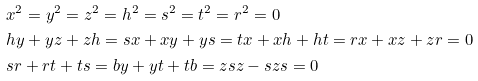Convert formula to latex. <formula><loc_0><loc_0><loc_500><loc_500>& x ^ { 2 } = y ^ { 2 } = z ^ { 2 } = h ^ { 2 } = s ^ { 2 } = t ^ { 2 } = r ^ { 2 } = 0 \\ & h y + y z + z h = s x + x y + y s = t x + x h + h t = r x + x z + z r = 0 \\ & s r + r t + t s = b y + y t + t b = z s z - s z s = 0</formula> 